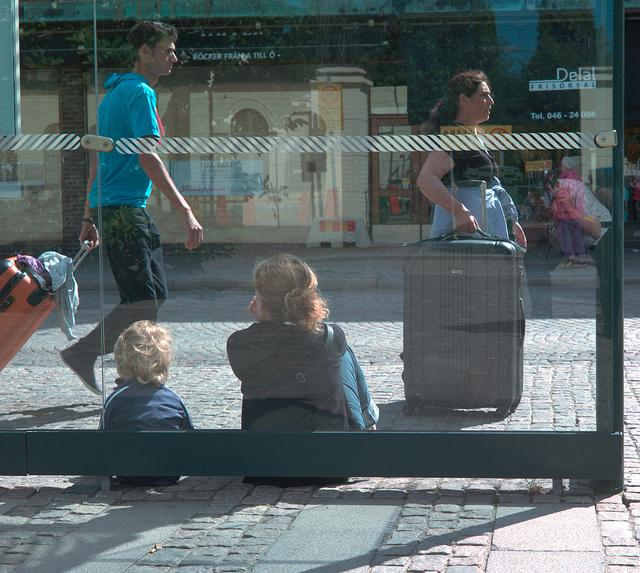Why is the white lines on the glass? decoration 